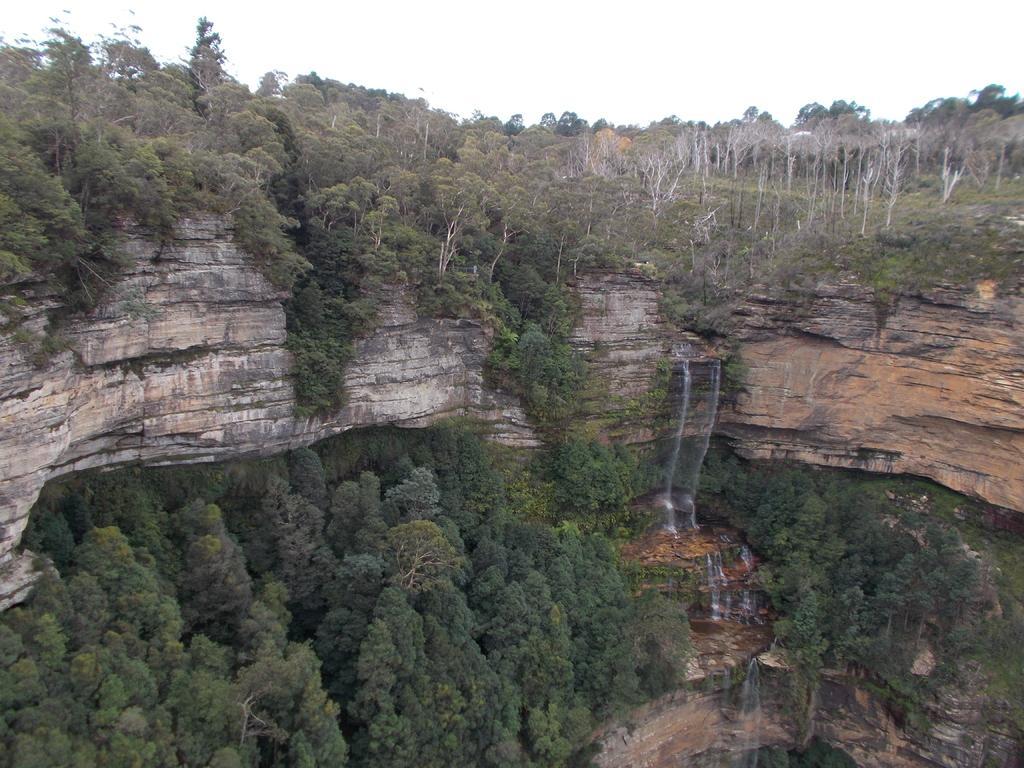Please provide a concise description of this image. In this image I can see many trees, mountains and the water flowing from the mountains. In the background I can see the white sky. 